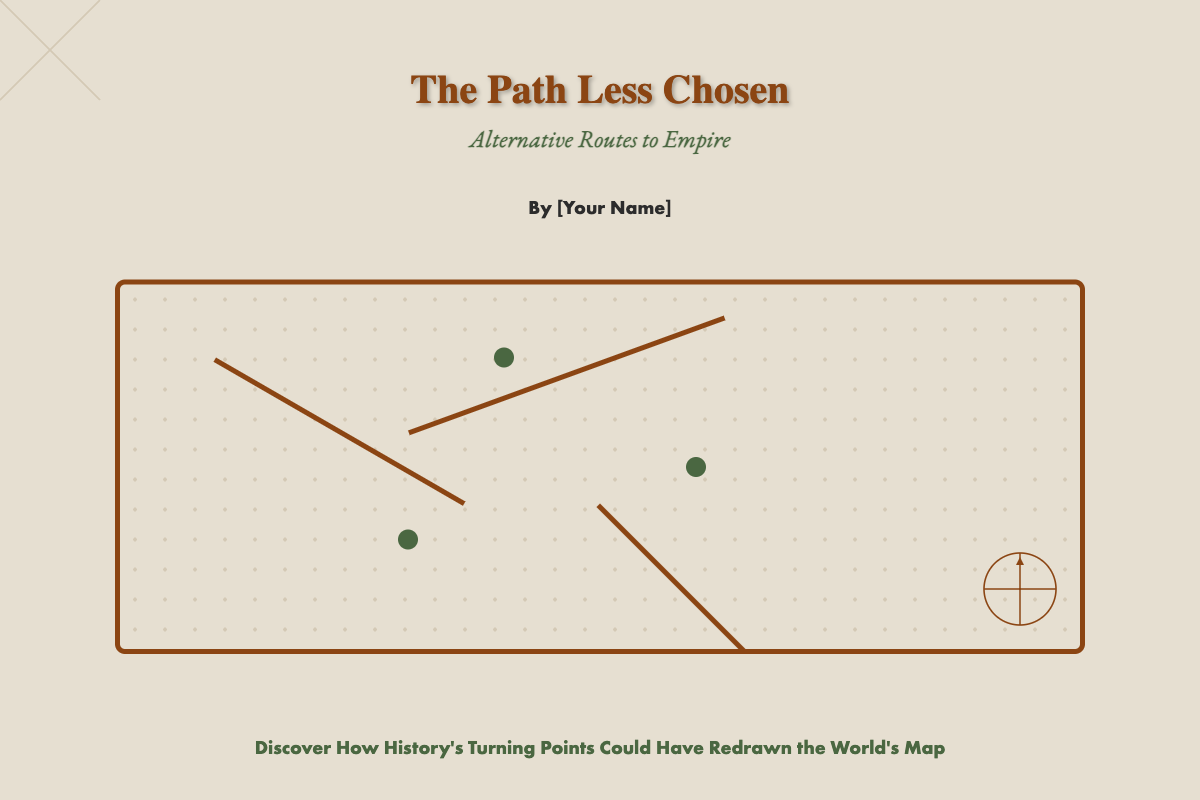What is the book title? The title of the book is prominently displayed at the top of the cover.
Answer: The Path Less Chosen What is the subtitle? The subtitle appears directly under the main title.
Answer: Alternative Routes to Empire Who is the author? The author's name is listed below the subtitle in the cover content.
Answer: [Your Name] What is the main color of the background? The background color of the book cover is specified in the style section.
Answer: #f0ebe1 How many paths are depicted in the map? The map in the cover design illustrates multiple distinct paths.
Answer: Three What color are the landmarks? The landmarks on the map are described by their styling in the document.
Answer: Dark green What type of gradient is used in the map background? The background pattern in the map area is outlined in the document's CSS.
Answer: Radial gradient What does the tagline suggest about the book's content? The tagline is displayed at the bottom of the cover content area.
Answer: History's Turning Points Where is the compass located on the cover? The compass position is explicitly defined in the visual design of the document.
Answer: Bottom right 